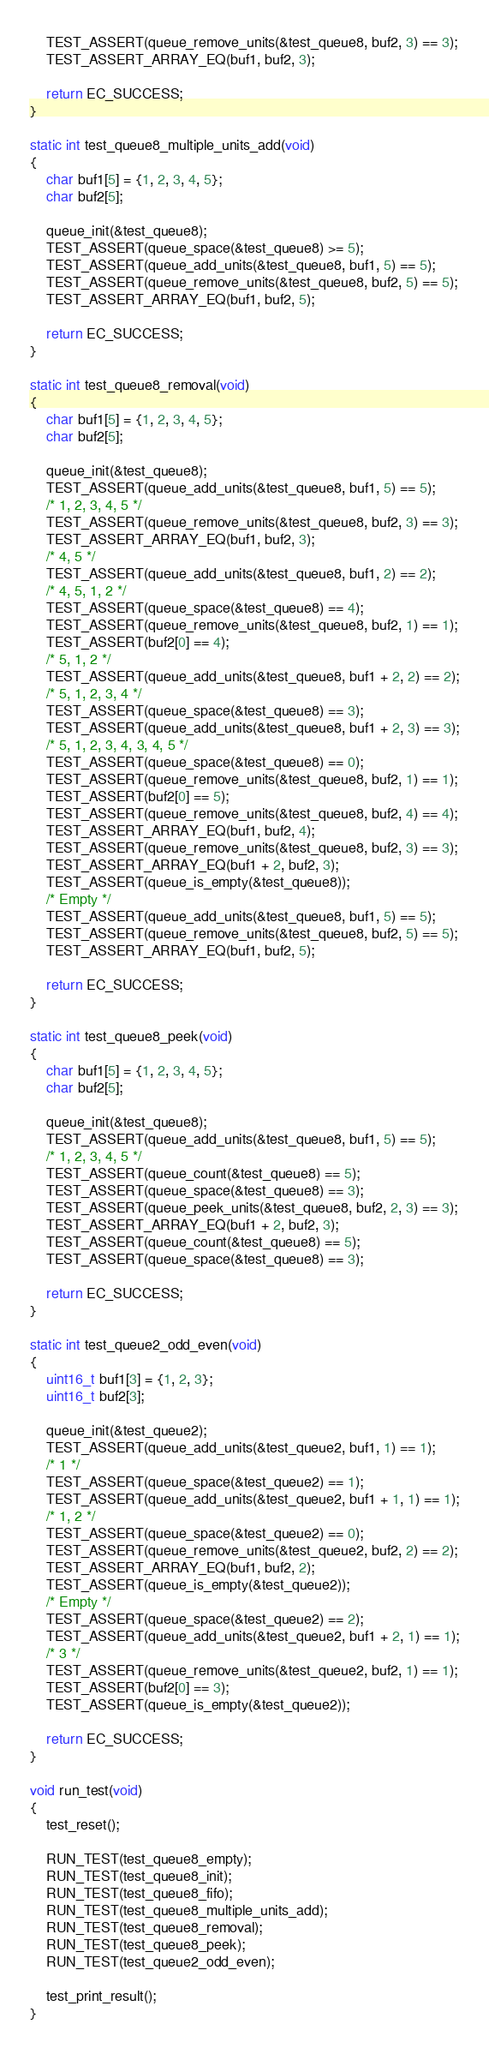<code> <loc_0><loc_0><loc_500><loc_500><_C_>
	TEST_ASSERT(queue_remove_units(&test_queue8, buf2, 3) == 3);
	TEST_ASSERT_ARRAY_EQ(buf1, buf2, 3);

	return EC_SUCCESS;
}

static int test_queue8_multiple_units_add(void)
{
	char buf1[5] = {1, 2, 3, 4, 5};
	char buf2[5];

	queue_init(&test_queue8);
	TEST_ASSERT(queue_space(&test_queue8) >= 5);
	TEST_ASSERT(queue_add_units(&test_queue8, buf1, 5) == 5);
	TEST_ASSERT(queue_remove_units(&test_queue8, buf2, 5) == 5);
	TEST_ASSERT_ARRAY_EQ(buf1, buf2, 5);

	return EC_SUCCESS;
}

static int test_queue8_removal(void)
{
	char buf1[5] = {1, 2, 3, 4, 5};
	char buf2[5];

	queue_init(&test_queue8);
	TEST_ASSERT(queue_add_units(&test_queue8, buf1, 5) == 5);
	/* 1, 2, 3, 4, 5 */
	TEST_ASSERT(queue_remove_units(&test_queue8, buf2, 3) == 3);
	TEST_ASSERT_ARRAY_EQ(buf1, buf2, 3);
	/* 4, 5 */
	TEST_ASSERT(queue_add_units(&test_queue8, buf1, 2) == 2);
	/* 4, 5, 1, 2 */
	TEST_ASSERT(queue_space(&test_queue8) == 4);
	TEST_ASSERT(queue_remove_units(&test_queue8, buf2, 1) == 1);
	TEST_ASSERT(buf2[0] == 4);
	/* 5, 1, 2 */
	TEST_ASSERT(queue_add_units(&test_queue8, buf1 + 2, 2) == 2);
	/* 5, 1, 2, 3, 4 */
	TEST_ASSERT(queue_space(&test_queue8) == 3);
	TEST_ASSERT(queue_add_units(&test_queue8, buf1 + 2, 3) == 3);
	/* 5, 1, 2, 3, 4, 3, 4, 5 */
	TEST_ASSERT(queue_space(&test_queue8) == 0);
	TEST_ASSERT(queue_remove_units(&test_queue8, buf2, 1) == 1);
	TEST_ASSERT(buf2[0] == 5);
	TEST_ASSERT(queue_remove_units(&test_queue8, buf2, 4) == 4);
	TEST_ASSERT_ARRAY_EQ(buf1, buf2, 4);
	TEST_ASSERT(queue_remove_units(&test_queue8, buf2, 3) == 3);
	TEST_ASSERT_ARRAY_EQ(buf1 + 2, buf2, 3);
	TEST_ASSERT(queue_is_empty(&test_queue8));
	/* Empty */
	TEST_ASSERT(queue_add_units(&test_queue8, buf1, 5) == 5);
	TEST_ASSERT(queue_remove_units(&test_queue8, buf2, 5) == 5);
	TEST_ASSERT_ARRAY_EQ(buf1, buf2, 5);

	return EC_SUCCESS;
}

static int test_queue8_peek(void)
{
	char buf1[5] = {1, 2, 3, 4, 5};
	char buf2[5];

	queue_init(&test_queue8);
	TEST_ASSERT(queue_add_units(&test_queue8, buf1, 5) == 5);
	/* 1, 2, 3, 4, 5 */
	TEST_ASSERT(queue_count(&test_queue8) == 5);
	TEST_ASSERT(queue_space(&test_queue8) == 3);
	TEST_ASSERT(queue_peek_units(&test_queue8, buf2, 2, 3) == 3);
	TEST_ASSERT_ARRAY_EQ(buf1 + 2, buf2, 3);
	TEST_ASSERT(queue_count(&test_queue8) == 5);
	TEST_ASSERT(queue_space(&test_queue8) == 3);

	return EC_SUCCESS;
}

static int test_queue2_odd_even(void)
{
	uint16_t buf1[3] = {1, 2, 3};
	uint16_t buf2[3];

	queue_init(&test_queue2);
	TEST_ASSERT(queue_add_units(&test_queue2, buf1, 1) == 1);
	/* 1 */
	TEST_ASSERT(queue_space(&test_queue2) == 1);
	TEST_ASSERT(queue_add_units(&test_queue2, buf1 + 1, 1) == 1);
	/* 1, 2 */
	TEST_ASSERT(queue_space(&test_queue2) == 0);
	TEST_ASSERT(queue_remove_units(&test_queue2, buf2, 2) == 2);
	TEST_ASSERT_ARRAY_EQ(buf1, buf2, 2);
	TEST_ASSERT(queue_is_empty(&test_queue2));
	/* Empty */
	TEST_ASSERT(queue_space(&test_queue2) == 2);
	TEST_ASSERT(queue_add_units(&test_queue2, buf1 + 2, 1) == 1);
	/* 3 */
	TEST_ASSERT(queue_remove_units(&test_queue2, buf2, 1) == 1);
	TEST_ASSERT(buf2[0] == 3);
	TEST_ASSERT(queue_is_empty(&test_queue2));

	return EC_SUCCESS;
}

void run_test(void)
{
	test_reset();

	RUN_TEST(test_queue8_empty);
	RUN_TEST(test_queue8_init);
	RUN_TEST(test_queue8_fifo);
	RUN_TEST(test_queue8_multiple_units_add);
	RUN_TEST(test_queue8_removal);
	RUN_TEST(test_queue8_peek);
	RUN_TEST(test_queue2_odd_even);

	test_print_result();
}
</code> 